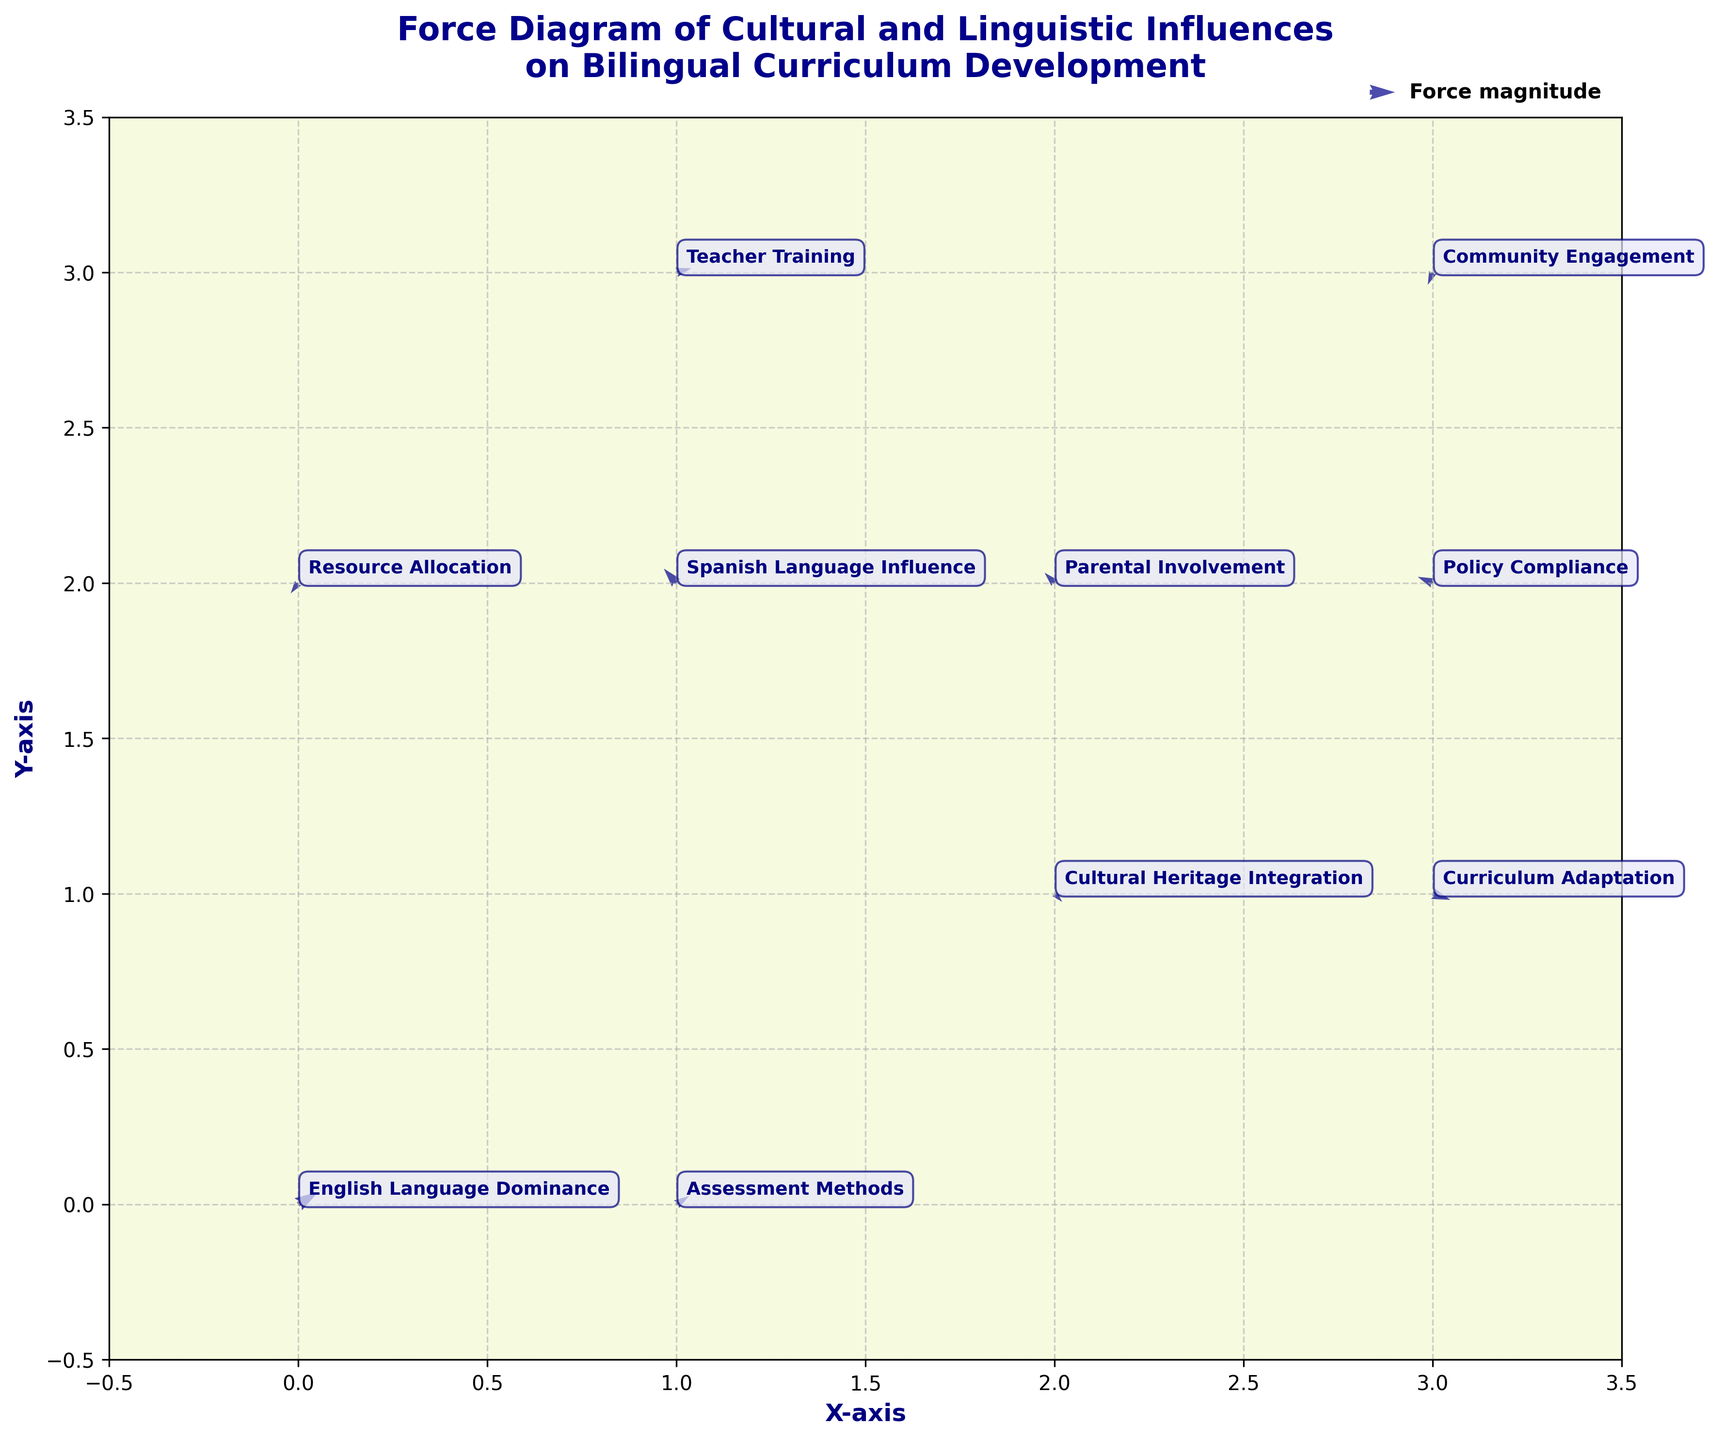Which axis represents the horizontal dimension in the plot? The plot has a labeled horizontal axis that indicates it as the 'X-axis'. One can identify it by looking for the axis label along the bottom of the plot.
Answer: X-axis What is the title of the figure? The title is located at the top of the plot and states the main purpose or subject of the plot. In this case, it reads, 'Force Diagram of Cultural and Linguistic Influences on Bilingual Curriculum Development'.
Answer: Force Diagram of Cultural and Linguistic Influences on Bilingual Curriculum Development What color are the arrows in the plot? By observing the arrows in the quiver plot, it is clear that they are colored 'dark blue'.
Answer: dark blue How many data points are represented in the plot? Each label corresponds to a data point. By counting the labels or arrows, one can see there are a total of 10 data points.
Answer: 10 Which influence is located at the coordinates (2, 1)? The coordinates (2, 1) can be referred to directly to find the label at that location. The label for this point is 'Cultural Heritage Integration'.
Answer: Cultural Heritage Integration Which influence has the longest vector? Compare the length of each arrow (vector) by its visual representation. The 'English Language Dominance' vector at (0, 0) appears to be the longest.
Answer: English Language Dominance What is the direction of the vector for 'Policy Compliance'? The vector for 'Policy Compliance' is at (3, 2) and its direction is visualized by its arrow pointing slightly downward and to the left, indicating a negative x-component and a positive y-component.
Answer: down-left Which influence has a vector pointing downward and to the right? By examining the arrows pointing downward and to the right, the labels that match this description can be identified. 'Cultural Heritage Integration' at (2, 1) and 'Community Engagement' at (3, 3) both match this description.
Answer: Cultural Heritage Integration, Community Engagement Which influence is closest to the origin (0, 0)? Determine the Euclidean distance of each point with coordinates (x, y) from the origin. The closest influence can be found by calculating the distance using the formula sqrt(x^2 + y^2). In this case, 'English Language Dominance' at (0, 0) is the origin itself, making it the closest.
Answer: English Language Dominance Comparing 'Teacher Training' and 'Parental Involvement', which has a larger horizontal influence component? Examine the u component (horizontal influence) for both 'Teacher Training' at (1, 3) with u=0.6, and 'Parental Involvement' at (2, 2) with u=-0.4. The larger value, 0.6, belongs to 'Teacher Training', indicating it has a larger horizontal influence component.
Answer: Teacher Training 